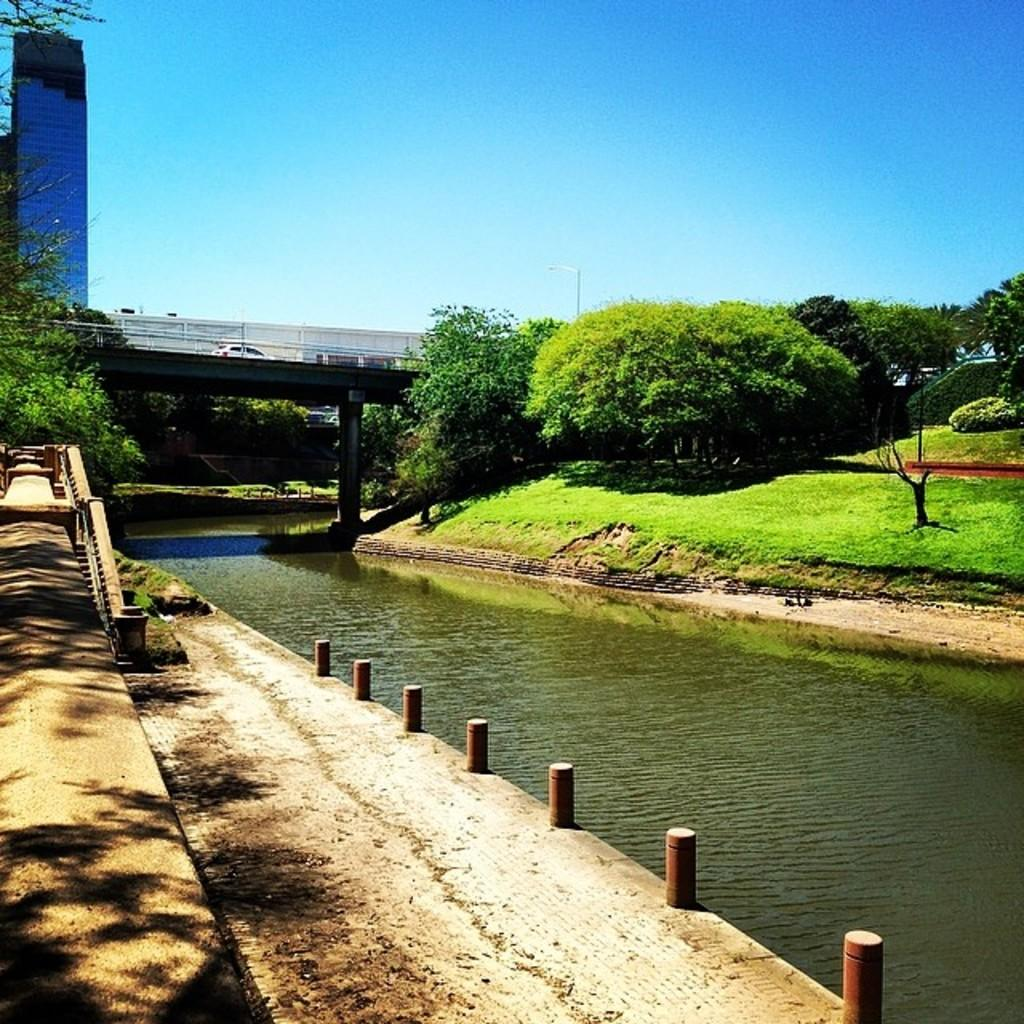What is at the bottom of the image? There is water at the bottom of the image. What can be seen on the right side of the image? There are trees, grass, a bridge, and a car on the right side of the image. What is visible in the sky in the image? There is sky visible in the image. What can be seen on the left side of the image? There are buildings, trees, and grass on the left side of the image. How many toes can be seen on the giants in the image? There are no giants present in the image, so it is not possible to determine the number of toes on any giants. 